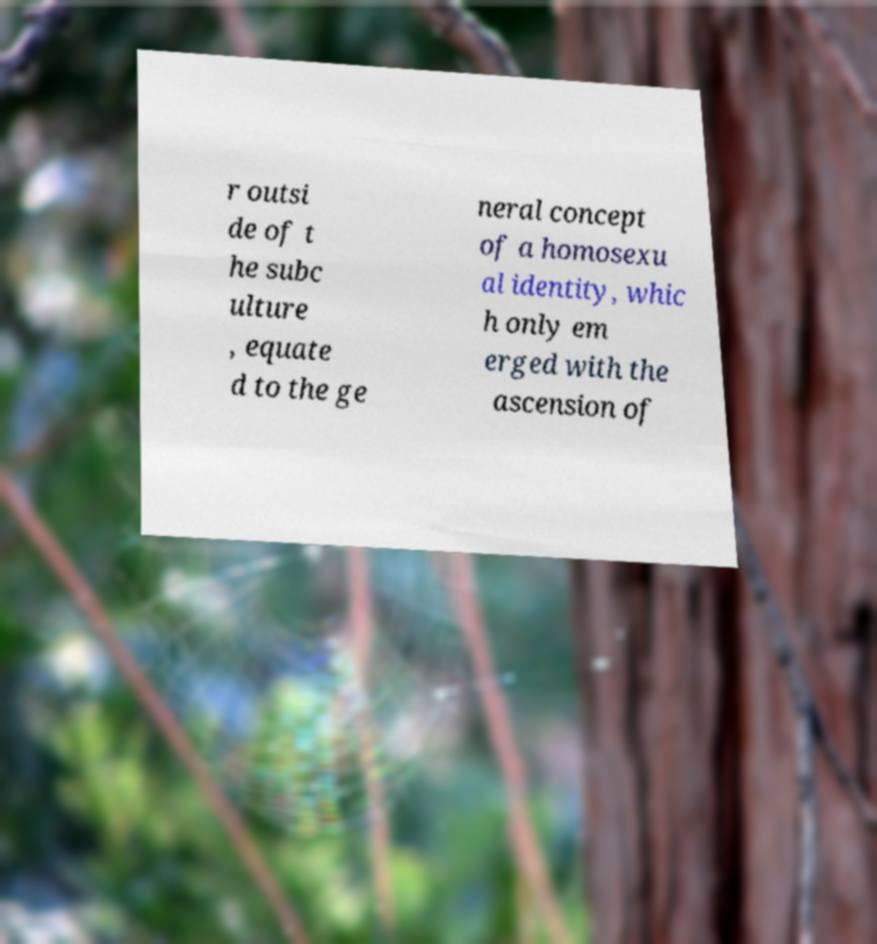Could you assist in decoding the text presented in this image and type it out clearly? r outsi de of t he subc ulture , equate d to the ge neral concept of a homosexu al identity, whic h only em erged with the ascension of 